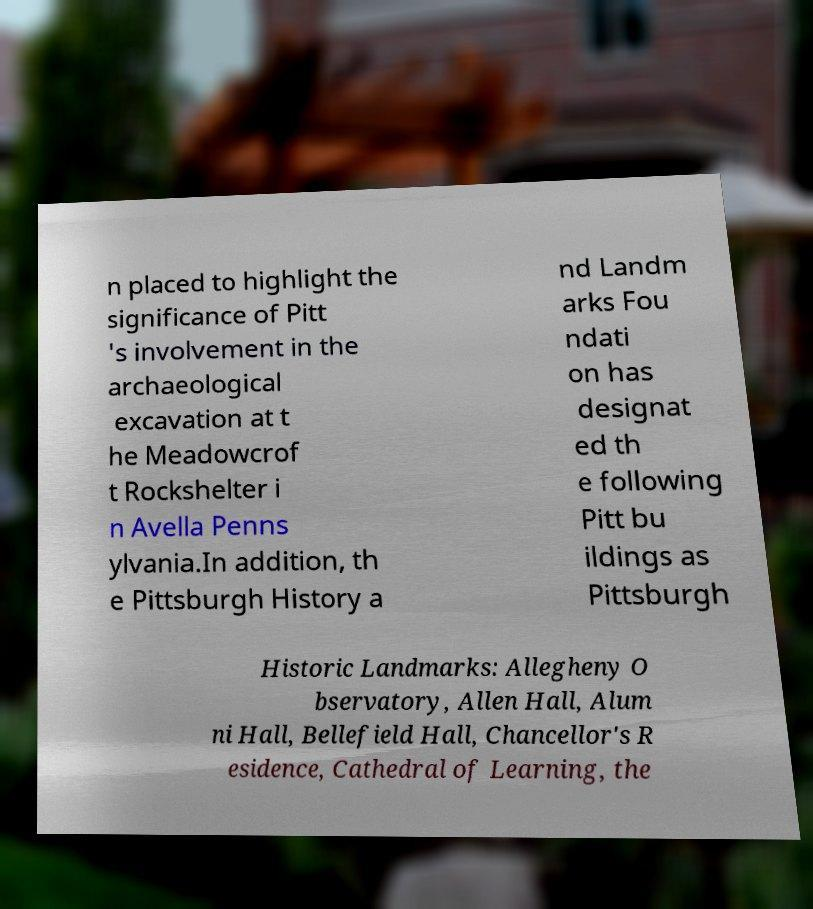For documentation purposes, I need the text within this image transcribed. Could you provide that? n placed to highlight the significance of Pitt 's involvement in the archaeological excavation at t he Meadowcrof t Rockshelter i n Avella Penns ylvania.In addition, th e Pittsburgh History a nd Landm arks Fou ndati on has designat ed th e following Pitt bu ildings as Pittsburgh Historic Landmarks: Allegheny O bservatory, Allen Hall, Alum ni Hall, Bellefield Hall, Chancellor's R esidence, Cathedral of Learning, the 